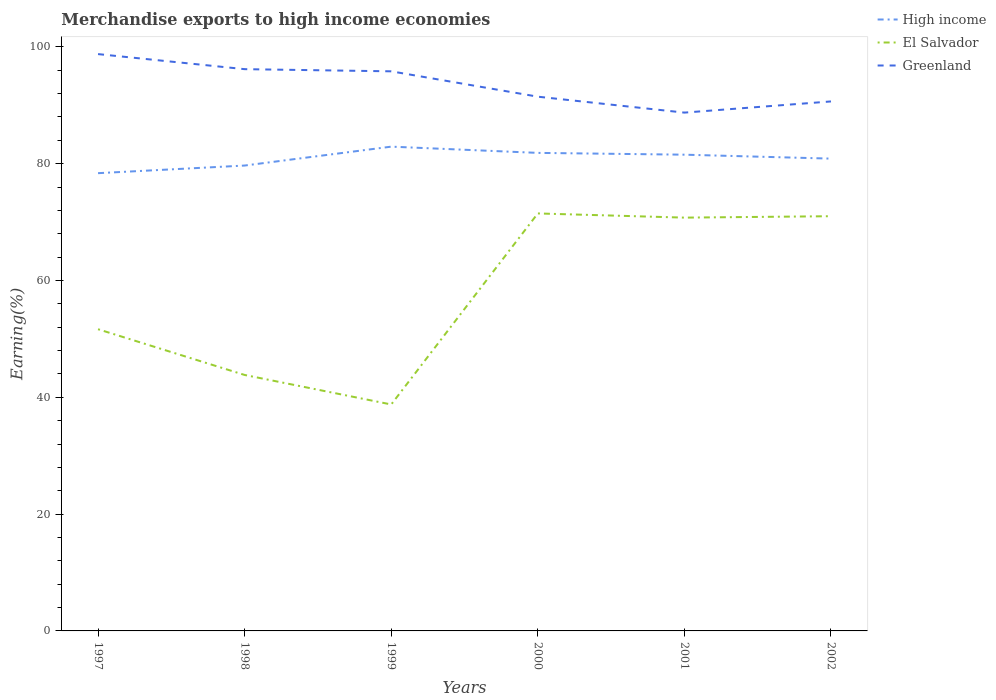Across all years, what is the maximum percentage of amount earned from merchandise exports in El Salvador?
Provide a short and direct response. 38.77. What is the total percentage of amount earned from merchandise exports in Greenland in the graph?
Keep it short and to the point. 7.44. What is the difference between the highest and the second highest percentage of amount earned from merchandise exports in Greenland?
Your answer should be very brief. 10.02. Is the percentage of amount earned from merchandise exports in Greenland strictly greater than the percentage of amount earned from merchandise exports in High income over the years?
Offer a very short reply. No. How many lines are there?
Offer a terse response. 3. How many years are there in the graph?
Keep it short and to the point. 6. What is the difference between two consecutive major ticks on the Y-axis?
Ensure brevity in your answer.  20. Does the graph contain any zero values?
Provide a succinct answer. No. Does the graph contain grids?
Offer a terse response. No. How many legend labels are there?
Your answer should be compact. 3. How are the legend labels stacked?
Your answer should be compact. Vertical. What is the title of the graph?
Your answer should be compact. Merchandise exports to high income economies. What is the label or title of the X-axis?
Provide a short and direct response. Years. What is the label or title of the Y-axis?
Keep it short and to the point. Earning(%). What is the Earning(%) of High income in 1997?
Keep it short and to the point. 78.38. What is the Earning(%) in El Salvador in 1997?
Ensure brevity in your answer.  51.66. What is the Earning(%) in Greenland in 1997?
Keep it short and to the point. 98.76. What is the Earning(%) of High income in 1998?
Keep it short and to the point. 79.68. What is the Earning(%) of El Salvador in 1998?
Your answer should be compact. 43.83. What is the Earning(%) in Greenland in 1998?
Keep it short and to the point. 96.18. What is the Earning(%) in High income in 1999?
Provide a short and direct response. 82.92. What is the Earning(%) of El Salvador in 1999?
Offer a terse response. 38.77. What is the Earning(%) in Greenland in 1999?
Provide a short and direct response. 95.81. What is the Earning(%) in High income in 2000?
Provide a succinct answer. 81.85. What is the Earning(%) of El Salvador in 2000?
Your answer should be compact. 71.48. What is the Earning(%) of Greenland in 2000?
Your answer should be very brief. 91.47. What is the Earning(%) in High income in 2001?
Provide a short and direct response. 81.54. What is the Earning(%) of El Salvador in 2001?
Provide a short and direct response. 70.76. What is the Earning(%) in Greenland in 2001?
Provide a short and direct response. 88.75. What is the Earning(%) of High income in 2002?
Offer a very short reply. 80.87. What is the Earning(%) of El Salvador in 2002?
Give a very brief answer. 71.01. What is the Earning(%) in Greenland in 2002?
Give a very brief answer. 90.66. Across all years, what is the maximum Earning(%) of High income?
Make the answer very short. 82.92. Across all years, what is the maximum Earning(%) of El Salvador?
Provide a succinct answer. 71.48. Across all years, what is the maximum Earning(%) in Greenland?
Offer a very short reply. 98.76. Across all years, what is the minimum Earning(%) of High income?
Your answer should be compact. 78.38. Across all years, what is the minimum Earning(%) in El Salvador?
Make the answer very short. 38.77. Across all years, what is the minimum Earning(%) in Greenland?
Your response must be concise. 88.75. What is the total Earning(%) of High income in the graph?
Your answer should be compact. 485.23. What is the total Earning(%) of El Salvador in the graph?
Ensure brevity in your answer.  347.51. What is the total Earning(%) of Greenland in the graph?
Give a very brief answer. 561.64. What is the difference between the Earning(%) of High income in 1997 and that in 1998?
Offer a terse response. -1.31. What is the difference between the Earning(%) in El Salvador in 1997 and that in 1998?
Provide a short and direct response. 7.83. What is the difference between the Earning(%) in Greenland in 1997 and that in 1998?
Make the answer very short. 2.58. What is the difference between the Earning(%) in High income in 1997 and that in 1999?
Your answer should be very brief. -4.54. What is the difference between the Earning(%) in El Salvador in 1997 and that in 1999?
Your answer should be very brief. 12.89. What is the difference between the Earning(%) of Greenland in 1997 and that in 1999?
Offer a terse response. 2.95. What is the difference between the Earning(%) of High income in 1997 and that in 2000?
Keep it short and to the point. -3.47. What is the difference between the Earning(%) in El Salvador in 1997 and that in 2000?
Your response must be concise. -19.82. What is the difference between the Earning(%) in Greenland in 1997 and that in 2000?
Your answer should be very brief. 7.29. What is the difference between the Earning(%) in High income in 1997 and that in 2001?
Provide a short and direct response. -3.17. What is the difference between the Earning(%) in El Salvador in 1997 and that in 2001?
Ensure brevity in your answer.  -19.11. What is the difference between the Earning(%) of Greenland in 1997 and that in 2001?
Provide a succinct answer. 10.02. What is the difference between the Earning(%) of High income in 1997 and that in 2002?
Provide a succinct answer. -2.49. What is the difference between the Earning(%) of El Salvador in 1997 and that in 2002?
Offer a very short reply. -19.35. What is the difference between the Earning(%) of Greenland in 1997 and that in 2002?
Ensure brevity in your answer.  8.11. What is the difference between the Earning(%) in High income in 1998 and that in 1999?
Make the answer very short. -3.24. What is the difference between the Earning(%) of El Salvador in 1998 and that in 1999?
Offer a very short reply. 5.05. What is the difference between the Earning(%) of Greenland in 1998 and that in 1999?
Give a very brief answer. 0.37. What is the difference between the Earning(%) of High income in 1998 and that in 2000?
Offer a terse response. -2.17. What is the difference between the Earning(%) in El Salvador in 1998 and that in 2000?
Provide a short and direct response. -27.65. What is the difference between the Earning(%) of Greenland in 1998 and that in 2000?
Your response must be concise. 4.71. What is the difference between the Earning(%) of High income in 1998 and that in 2001?
Your answer should be very brief. -1.86. What is the difference between the Earning(%) in El Salvador in 1998 and that in 2001?
Offer a very short reply. -26.94. What is the difference between the Earning(%) in Greenland in 1998 and that in 2001?
Your response must be concise. 7.44. What is the difference between the Earning(%) of High income in 1998 and that in 2002?
Ensure brevity in your answer.  -1.19. What is the difference between the Earning(%) in El Salvador in 1998 and that in 2002?
Your answer should be very brief. -27.18. What is the difference between the Earning(%) in Greenland in 1998 and that in 2002?
Provide a short and direct response. 5.53. What is the difference between the Earning(%) of High income in 1999 and that in 2000?
Offer a very short reply. 1.07. What is the difference between the Earning(%) of El Salvador in 1999 and that in 2000?
Provide a short and direct response. -32.71. What is the difference between the Earning(%) in Greenland in 1999 and that in 2000?
Give a very brief answer. 4.34. What is the difference between the Earning(%) in High income in 1999 and that in 2001?
Your answer should be very brief. 1.38. What is the difference between the Earning(%) in El Salvador in 1999 and that in 2001?
Your response must be concise. -31.99. What is the difference between the Earning(%) in Greenland in 1999 and that in 2001?
Offer a very short reply. 7.07. What is the difference between the Earning(%) of High income in 1999 and that in 2002?
Make the answer very short. 2.05. What is the difference between the Earning(%) in El Salvador in 1999 and that in 2002?
Give a very brief answer. -32.23. What is the difference between the Earning(%) of Greenland in 1999 and that in 2002?
Provide a short and direct response. 5.16. What is the difference between the Earning(%) of High income in 2000 and that in 2001?
Keep it short and to the point. 0.31. What is the difference between the Earning(%) in El Salvador in 2000 and that in 2001?
Your answer should be very brief. 0.72. What is the difference between the Earning(%) of Greenland in 2000 and that in 2001?
Give a very brief answer. 2.73. What is the difference between the Earning(%) of High income in 2000 and that in 2002?
Provide a short and direct response. 0.98. What is the difference between the Earning(%) in El Salvador in 2000 and that in 2002?
Offer a terse response. 0.47. What is the difference between the Earning(%) of Greenland in 2000 and that in 2002?
Ensure brevity in your answer.  0.82. What is the difference between the Earning(%) of High income in 2001 and that in 2002?
Your answer should be compact. 0.67. What is the difference between the Earning(%) in El Salvador in 2001 and that in 2002?
Offer a very short reply. -0.24. What is the difference between the Earning(%) of Greenland in 2001 and that in 2002?
Give a very brief answer. -1.91. What is the difference between the Earning(%) of High income in 1997 and the Earning(%) of El Salvador in 1998?
Provide a short and direct response. 34.55. What is the difference between the Earning(%) in High income in 1997 and the Earning(%) in Greenland in 1998?
Provide a succinct answer. -17.81. What is the difference between the Earning(%) of El Salvador in 1997 and the Earning(%) of Greenland in 1998?
Provide a succinct answer. -44.53. What is the difference between the Earning(%) in High income in 1997 and the Earning(%) in El Salvador in 1999?
Give a very brief answer. 39.6. What is the difference between the Earning(%) of High income in 1997 and the Earning(%) of Greenland in 1999?
Give a very brief answer. -17.44. What is the difference between the Earning(%) in El Salvador in 1997 and the Earning(%) in Greenland in 1999?
Keep it short and to the point. -44.16. What is the difference between the Earning(%) of High income in 1997 and the Earning(%) of El Salvador in 2000?
Provide a short and direct response. 6.9. What is the difference between the Earning(%) of High income in 1997 and the Earning(%) of Greenland in 2000?
Your response must be concise. -13.1. What is the difference between the Earning(%) in El Salvador in 1997 and the Earning(%) in Greenland in 2000?
Provide a succinct answer. -39.82. What is the difference between the Earning(%) in High income in 1997 and the Earning(%) in El Salvador in 2001?
Your response must be concise. 7.61. What is the difference between the Earning(%) of High income in 1997 and the Earning(%) of Greenland in 2001?
Make the answer very short. -10.37. What is the difference between the Earning(%) of El Salvador in 1997 and the Earning(%) of Greenland in 2001?
Provide a short and direct response. -37.09. What is the difference between the Earning(%) in High income in 1997 and the Earning(%) in El Salvador in 2002?
Your answer should be very brief. 7.37. What is the difference between the Earning(%) of High income in 1997 and the Earning(%) of Greenland in 2002?
Keep it short and to the point. -12.28. What is the difference between the Earning(%) in El Salvador in 1997 and the Earning(%) in Greenland in 2002?
Make the answer very short. -39. What is the difference between the Earning(%) of High income in 1998 and the Earning(%) of El Salvador in 1999?
Provide a short and direct response. 40.91. What is the difference between the Earning(%) in High income in 1998 and the Earning(%) in Greenland in 1999?
Offer a very short reply. -16.13. What is the difference between the Earning(%) in El Salvador in 1998 and the Earning(%) in Greenland in 1999?
Provide a succinct answer. -51.99. What is the difference between the Earning(%) in High income in 1998 and the Earning(%) in El Salvador in 2000?
Your answer should be very brief. 8.2. What is the difference between the Earning(%) in High income in 1998 and the Earning(%) in Greenland in 2000?
Your response must be concise. -11.79. What is the difference between the Earning(%) of El Salvador in 1998 and the Earning(%) of Greenland in 2000?
Give a very brief answer. -47.65. What is the difference between the Earning(%) in High income in 1998 and the Earning(%) in El Salvador in 2001?
Give a very brief answer. 8.92. What is the difference between the Earning(%) of High income in 1998 and the Earning(%) of Greenland in 2001?
Provide a short and direct response. -9.06. What is the difference between the Earning(%) of El Salvador in 1998 and the Earning(%) of Greenland in 2001?
Provide a succinct answer. -44.92. What is the difference between the Earning(%) of High income in 1998 and the Earning(%) of El Salvador in 2002?
Ensure brevity in your answer.  8.67. What is the difference between the Earning(%) in High income in 1998 and the Earning(%) in Greenland in 2002?
Give a very brief answer. -10.98. What is the difference between the Earning(%) of El Salvador in 1998 and the Earning(%) of Greenland in 2002?
Provide a short and direct response. -46.83. What is the difference between the Earning(%) in High income in 1999 and the Earning(%) in El Salvador in 2000?
Offer a very short reply. 11.44. What is the difference between the Earning(%) of High income in 1999 and the Earning(%) of Greenland in 2000?
Offer a terse response. -8.56. What is the difference between the Earning(%) in El Salvador in 1999 and the Earning(%) in Greenland in 2000?
Provide a succinct answer. -52.7. What is the difference between the Earning(%) of High income in 1999 and the Earning(%) of El Salvador in 2001?
Provide a succinct answer. 12.15. What is the difference between the Earning(%) of High income in 1999 and the Earning(%) of Greenland in 2001?
Offer a terse response. -5.83. What is the difference between the Earning(%) of El Salvador in 1999 and the Earning(%) of Greenland in 2001?
Give a very brief answer. -49.97. What is the difference between the Earning(%) in High income in 1999 and the Earning(%) in El Salvador in 2002?
Give a very brief answer. 11.91. What is the difference between the Earning(%) of High income in 1999 and the Earning(%) of Greenland in 2002?
Make the answer very short. -7.74. What is the difference between the Earning(%) of El Salvador in 1999 and the Earning(%) of Greenland in 2002?
Your answer should be compact. -51.89. What is the difference between the Earning(%) of High income in 2000 and the Earning(%) of El Salvador in 2001?
Offer a very short reply. 11.08. What is the difference between the Earning(%) of High income in 2000 and the Earning(%) of Greenland in 2001?
Your response must be concise. -6.9. What is the difference between the Earning(%) in El Salvador in 2000 and the Earning(%) in Greenland in 2001?
Offer a very short reply. -17.26. What is the difference between the Earning(%) in High income in 2000 and the Earning(%) in El Salvador in 2002?
Your answer should be compact. 10.84. What is the difference between the Earning(%) of High income in 2000 and the Earning(%) of Greenland in 2002?
Your answer should be compact. -8.81. What is the difference between the Earning(%) of El Salvador in 2000 and the Earning(%) of Greenland in 2002?
Give a very brief answer. -19.18. What is the difference between the Earning(%) of High income in 2001 and the Earning(%) of El Salvador in 2002?
Offer a terse response. 10.53. What is the difference between the Earning(%) of High income in 2001 and the Earning(%) of Greenland in 2002?
Make the answer very short. -9.12. What is the difference between the Earning(%) in El Salvador in 2001 and the Earning(%) in Greenland in 2002?
Make the answer very short. -19.89. What is the average Earning(%) of High income per year?
Your answer should be compact. 80.87. What is the average Earning(%) in El Salvador per year?
Provide a succinct answer. 57.92. What is the average Earning(%) in Greenland per year?
Your answer should be compact. 93.61. In the year 1997, what is the difference between the Earning(%) of High income and Earning(%) of El Salvador?
Make the answer very short. 26.72. In the year 1997, what is the difference between the Earning(%) in High income and Earning(%) in Greenland?
Offer a very short reply. -20.39. In the year 1997, what is the difference between the Earning(%) in El Salvador and Earning(%) in Greenland?
Offer a very short reply. -47.11. In the year 1998, what is the difference between the Earning(%) of High income and Earning(%) of El Salvador?
Your answer should be very brief. 35.85. In the year 1998, what is the difference between the Earning(%) in High income and Earning(%) in Greenland?
Offer a terse response. -16.5. In the year 1998, what is the difference between the Earning(%) of El Salvador and Earning(%) of Greenland?
Make the answer very short. -52.36. In the year 1999, what is the difference between the Earning(%) in High income and Earning(%) in El Salvador?
Offer a very short reply. 44.15. In the year 1999, what is the difference between the Earning(%) in High income and Earning(%) in Greenland?
Offer a terse response. -12.9. In the year 1999, what is the difference between the Earning(%) of El Salvador and Earning(%) of Greenland?
Keep it short and to the point. -57.04. In the year 2000, what is the difference between the Earning(%) in High income and Earning(%) in El Salvador?
Provide a short and direct response. 10.37. In the year 2000, what is the difference between the Earning(%) of High income and Earning(%) of Greenland?
Provide a short and direct response. -9.62. In the year 2000, what is the difference between the Earning(%) of El Salvador and Earning(%) of Greenland?
Make the answer very short. -19.99. In the year 2001, what is the difference between the Earning(%) in High income and Earning(%) in El Salvador?
Make the answer very short. 10.78. In the year 2001, what is the difference between the Earning(%) of High income and Earning(%) of Greenland?
Keep it short and to the point. -7.2. In the year 2001, what is the difference between the Earning(%) in El Salvador and Earning(%) in Greenland?
Your response must be concise. -17.98. In the year 2002, what is the difference between the Earning(%) in High income and Earning(%) in El Salvador?
Ensure brevity in your answer.  9.86. In the year 2002, what is the difference between the Earning(%) of High income and Earning(%) of Greenland?
Your answer should be very brief. -9.79. In the year 2002, what is the difference between the Earning(%) of El Salvador and Earning(%) of Greenland?
Keep it short and to the point. -19.65. What is the ratio of the Earning(%) of High income in 1997 to that in 1998?
Ensure brevity in your answer.  0.98. What is the ratio of the Earning(%) of El Salvador in 1997 to that in 1998?
Offer a terse response. 1.18. What is the ratio of the Earning(%) of Greenland in 1997 to that in 1998?
Make the answer very short. 1.03. What is the ratio of the Earning(%) of High income in 1997 to that in 1999?
Provide a succinct answer. 0.95. What is the ratio of the Earning(%) in El Salvador in 1997 to that in 1999?
Give a very brief answer. 1.33. What is the ratio of the Earning(%) in Greenland in 1997 to that in 1999?
Your answer should be very brief. 1.03. What is the ratio of the Earning(%) in High income in 1997 to that in 2000?
Keep it short and to the point. 0.96. What is the ratio of the Earning(%) of El Salvador in 1997 to that in 2000?
Ensure brevity in your answer.  0.72. What is the ratio of the Earning(%) of Greenland in 1997 to that in 2000?
Provide a succinct answer. 1.08. What is the ratio of the Earning(%) of High income in 1997 to that in 2001?
Keep it short and to the point. 0.96. What is the ratio of the Earning(%) of El Salvador in 1997 to that in 2001?
Ensure brevity in your answer.  0.73. What is the ratio of the Earning(%) of Greenland in 1997 to that in 2001?
Your answer should be compact. 1.11. What is the ratio of the Earning(%) of High income in 1997 to that in 2002?
Give a very brief answer. 0.97. What is the ratio of the Earning(%) in El Salvador in 1997 to that in 2002?
Give a very brief answer. 0.73. What is the ratio of the Earning(%) of Greenland in 1997 to that in 2002?
Provide a short and direct response. 1.09. What is the ratio of the Earning(%) in El Salvador in 1998 to that in 1999?
Give a very brief answer. 1.13. What is the ratio of the Earning(%) of Greenland in 1998 to that in 1999?
Offer a very short reply. 1. What is the ratio of the Earning(%) in High income in 1998 to that in 2000?
Your answer should be compact. 0.97. What is the ratio of the Earning(%) in El Salvador in 1998 to that in 2000?
Your answer should be very brief. 0.61. What is the ratio of the Earning(%) in Greenland in 1998 to that in 2000?
Offer a terse response. 1.05. What is the ratio of the Earning(%) of High income in 1998 to that in 2001?
Your answer should be very brief. 0.98. What is the ratio of the Earning(%) in El Salvador in 1998 to that in 2001?
Your answer should be very brief. 0.62. What is the ratio of the Earning(%) in Greenland in 1998 to that in 2001?
Provide a short and direct response. 1.08. What is the ratio of the Earning(%) of El Salvador in 1998 to that in 2002?
Give a very brief answer. 0.62. What is the ratio of the Earning(%) of Greenland in 1998 to that in 2002?
Provide a short and direct response. 1.06. What is the ratio of the Earning(%) of High income in 1999 to that in 2000?
Provide a succinct answer. 1.01. What is the ratio of the Earning(%) in El Salvador in 1999 to that in 2000?
Ensure brevity in your answer.  0.54. What is the ratio of the Earning(%) of Greenland in 1999 to that in 2000?
Provide a succinct answer. 1.05. What is the ratio of the Earning(%) in High income in 1999 to that in 2001?
Your answer should be very brief. 1.02. What is the ratio of the Earning(%) of El Salvador in 1999 to that in 2001?
Your answer should be very brief. 0.55. What is the ratio of the Earning(%) in Greenland in 1999 to that in 2001?
Your response must be concise. 1.08. What is the ratio of the Earning(%) of High income in 1999 to that in 2002?
Make the answer very short. 1.03. What is the ratio of the Earning(%) in El Salvador in 1999 to that in 2002?
Give a very brief answer. 0.55. What is the ratio of the Earning(%) in Greenland in 1999 to that in 2002?
Offer a very short reply. 1.06. What is the ratio of the Earning(%) in Greenland in 2000 to that in 2001?
Provide a short and direct response. 1.03. What is the ratio of the Earning(%) in High income in 2000 to that in 2002?
Keep it short and to the point. 1.01. What is the ratio of the Earning(%) in El Salvador in 2000 to that in 2002?
Provide a succinct answer. 1.01. What is the ratio of the Earning(%) in High income in 2001 to that in 2002?
Give a very brief answer. 1.01. What is the ratio of the Earning(%) in El Salvador in 2001 to that in 2002?
Provide a short and direct response. 1. What is the ratio of the Earning(%) in Greenland in 2001 to that in 2002?
Offer a very short reply. 0.98. What is the difference between the highest and the second highest Earning(%) of High income?
Your answer should be very brief. 1.07. What is the difference between the highest and the second highest Earning(%) of El Salvador?
Provide a short and direct response. 0.47. What is the difference between the highest and the second highest Earning(%) in Greenland?
Give a very brief answer. 2.58. What is the difference between the highest and the lowest Earning(%) in High income?
Your response must be concise. 4.54. What is the difference between the highest and the lowest Earning(%) of El Salvador?
Your answer should be compact. 32.71. What is the difference between the highest and the lowest Earning(%) of Greenland?
Give a very brief answer. 10.02. 